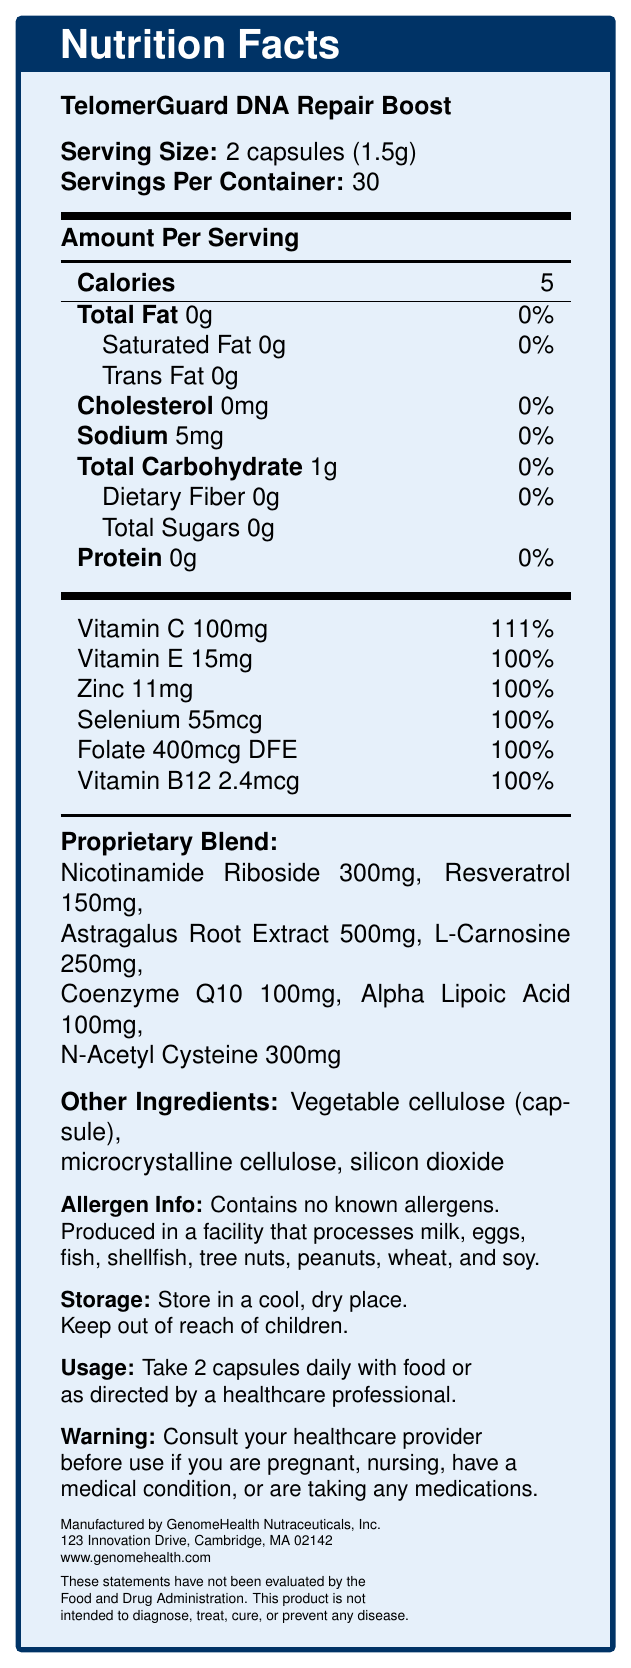what is the serving size of TelomerGuard DNA Repair Boost? The serving size is explicitly mentioned as "2 capsules (1.5g)" under the product name.
Answer: 2 capsules (1.5g) how many calories are in one serving of this product? In the document, it's stated that one serving contains 5 calories.
Answer: 5 calories how much Vitamin C is in a serving? The document lists the amount of Vitamin C as 100mg per serving.
Answer: 100mg how much sodium does one serving contain? Sodium content is shown as 5mg per serving in the document.
Answer: 5mg does the product contain any protein? Protein content is listed as 0g in the Nutrition Facts.
Answer: No what are the main ingredients in the proprietary blend? (Choose all that apply) 
A. Acrylamide 
B. Resveratrol 
C. Astragalus Root Extract 
D. L-Carnosine 
E. Coenzyme Q10 The proprietary blend includes Resveratrol, Astragalus Root Extract, L-Carnosine, and Coenzyme Q10.
Answer: B, C, D, E which of the following vitamins are part of this supplement? 
1. Vitamin A 
2. Vitamin B12 
3. Vitamin D The Nutrition Facts list Vitamin B12 as one of the vitamins included, but not Vitamins A or D.
Answer: 2 is the product safe for people with common food allergies? The allergen info states that it contains no known allergens, though it is produced in a facility that processes several allergens.
Answer: Yes what should you do before taking the product if you are pregnant? The warning indicates you should consult your healthcare provider before use if pregnant.
Answer: Consult your healthcare provider summarize the purpose and nature of TelomerGuard DNA Repair Boost The document details that the product is meant for DNA repair and telomere support, lists various ingredients and nutrients, provides allergen info, and includes usage and storage directions, as well as a warning.
Answer: TelomerGuard DNA Repair Boost is a dietary supplement in capsule form designed to support DNA repair and telomere maintenance. It contains various vitamins and a proprietary blend of compounds, with no known allergens and specific usage instructions. how much L-Carnosine is in one serving? The amount of L-Carnosine in the proprietary blend is specifically 250mg per serving.
Answer: 250mg which company manufactures TelomerGuard DNA Repair Boost? The manufacturer is specified as GenomeHealth Nutraceuticals, Inc.
Answer: GenomeHealth Nutraceuticals, Inc. what is the storage instruction for the product? The storage instructions are clearly mentioned in the document.
Answer: Store in a cool, dry place. Keep out of reach of children. how many servings are there per container? The document lists the servings per container as 30.
Answer: 30 can I determine the effectiveness of this product in treating diseases from the document? The document includes an FDA disclaimer stating that these statements have not been evaluated by the FDA and that the product is not intended to diagnose, treat, cure, or prevent any disease.
Answer: No 